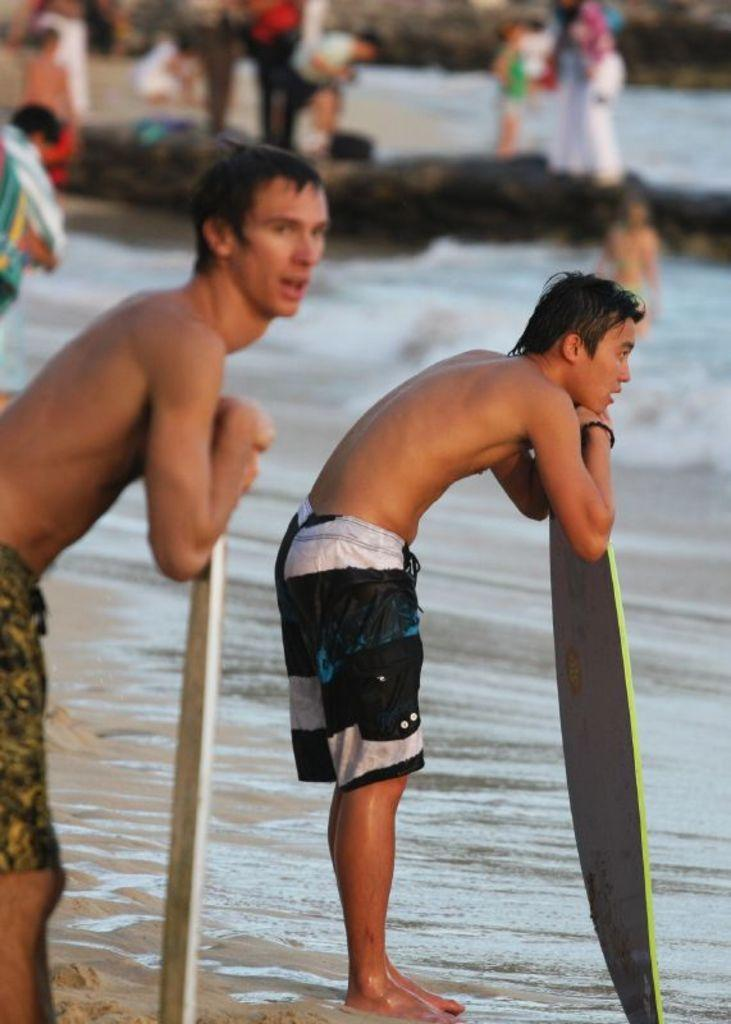How many people are in the image? There are two guys in the image. What are the guys holding in the image? The guys are holding a rowboat. Where are the guys standing in the image? The guys are standing near the beach. What type of hair is visible on the dolls in the image? There are no dolls present in the image; it features two guys holding a rowboat near the beach. 